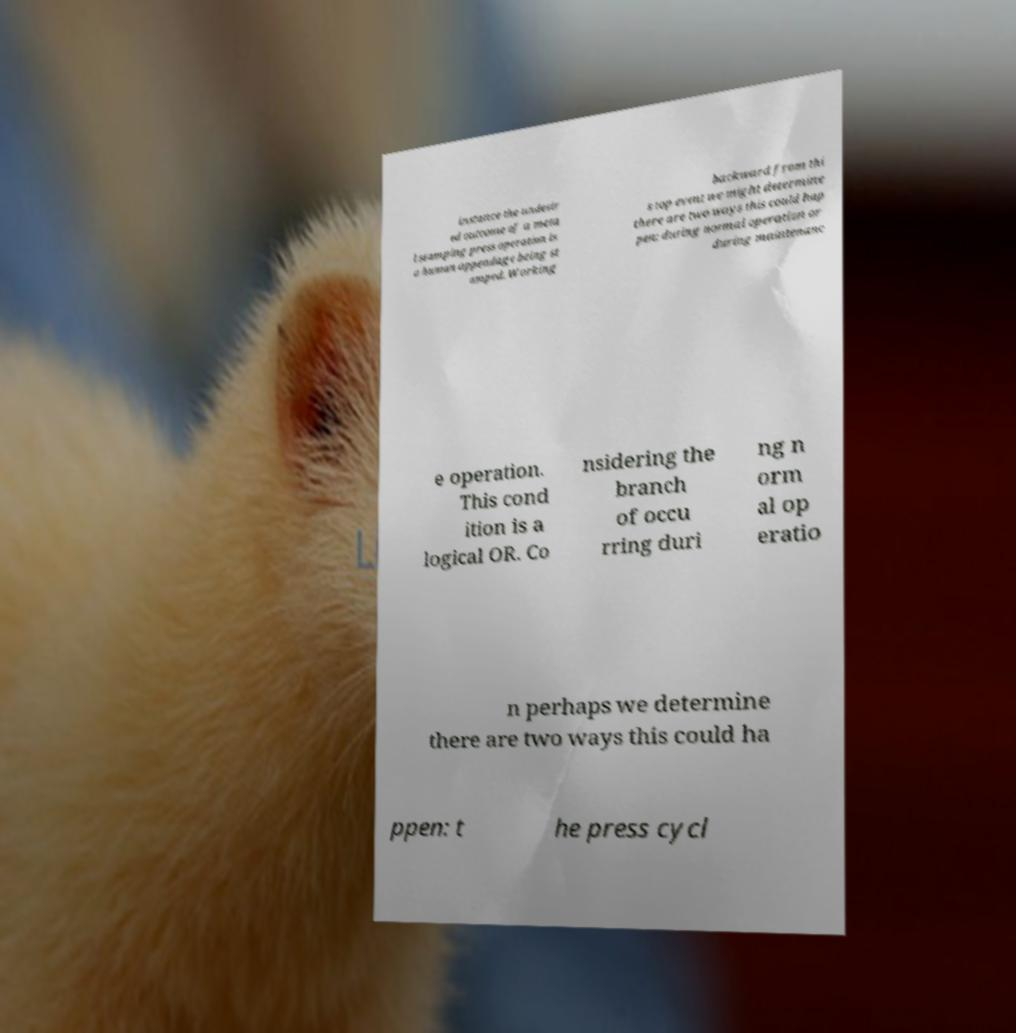Could you assist in decoding the text presented in this image and type it out clearly? instance the undesir ed outcome of a meta l stamping press operation is a human appendage being st amped. Working backward from thi s top event we might determine there are two ways this could hap pen: during normal operation or during maintenanc e operation. This cond ition is a logical OR. Co nsidering the branch of occu rring duri ng n orm al op eratio n perhaps we determine there are two ways this could ha ppen: t he press cycl 